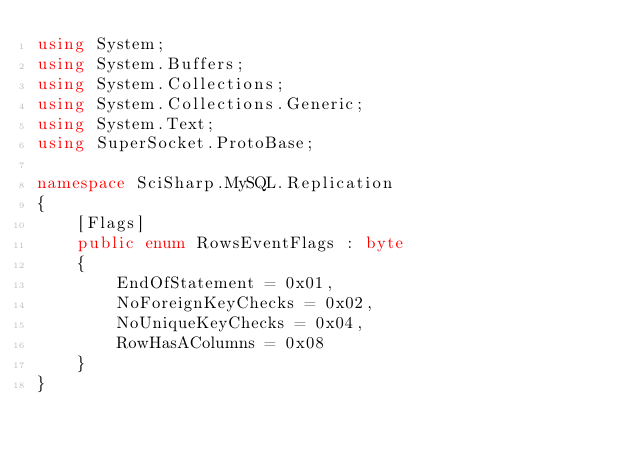Convert code to text. <code><loc_0><loc_0><loc_500><loc_500><_C#_>using System;
using System.Buffers;
using System.Collections;
using System.Collections.Generic;
using System.Text;
using SuperSocket.ProtoBase;

namespace SciSharp.MySQL.Replication
{
    [Flags]
    public enum RowsEventFlags : byte
    {
        EndOfStatement = 0x01,
        NoForeignKeyChecks = 0x02,
        NoUniqueKeyChecks = 0x04,
        RowHasAColumns = 0x08    
    }
}
</code> 